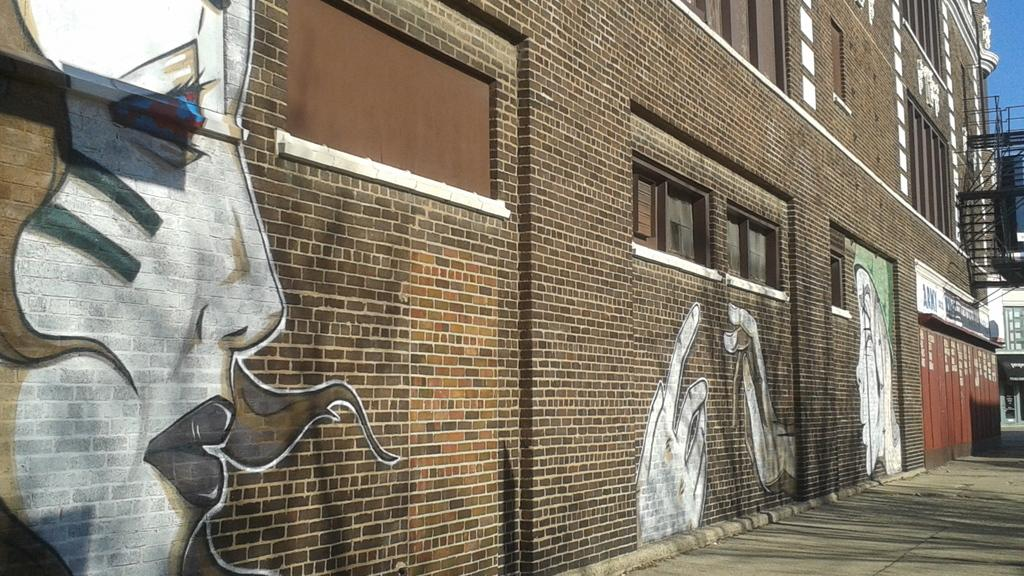What can be seen on the wall in the image? There are paintings, windows, and ventilators on the wall in the image. What is located at the bottom of the image? There is a footpath at the bottom of the image. What type of suit is the fireman wearing in the image? There is no fireman or suit present in the image. What is the fireman using to put out the paper fire in the image? There is no fireman, suit, or paper fire present in the image. 